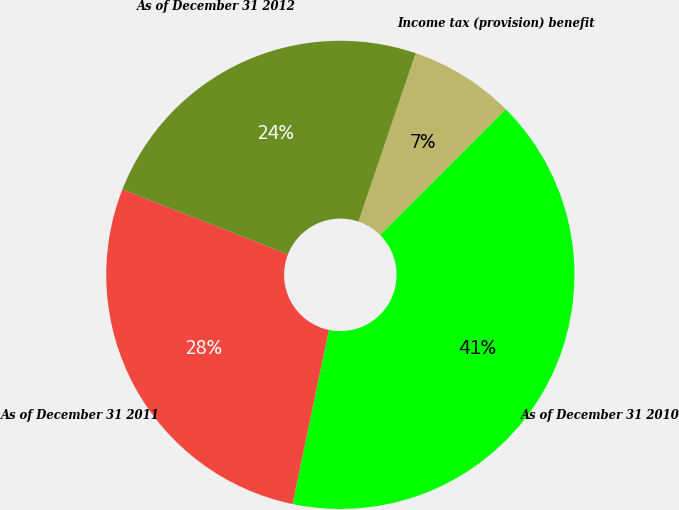Convert chart to OTSL. <chart><loc_0><loc_0><loc_500><loc_500><pie_chart><fcel>Income tax (provision) benefit<fcel>As of December 31 2010<fcel>As of December 31 2011<fcel>As of December 31 2012<nl><fcel>7.28%<fcel>40.78%<fcel>27.67%<fcel>24.27%<nl></chart> 